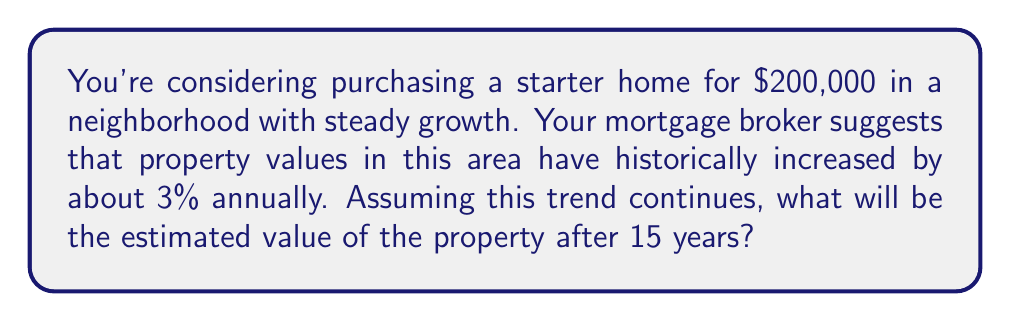Provide a solution to this math problem. To solve this problem, we'll use an exponential growth model. The formula for exponential growth is:

$$A = P(1 + r)^t$$

Where:
$A$ = Final amount
$P$ = Initial principal balance
$r$ = Annual growth rate (as a decimal)
$t$ = Time in years

Given:
$P = $200,000 (initial property value)
$r = 0.03$ (3% annual growth rate)
$t = 15$ years

Let's plug these values into our formula:

$$A = 200,000(1 + 0.03)^{15}$$

Now, let's calculate step by step:

1. Calculate $(1 + 0.03)^{15}$:
   $$(1.03)^{15} \approx 1.5580$$

2. Multiply the result by the initial value:
   $$200,000 \times 1.5580 = 311,600$$

Therefore, after 15 years, the estimated value of the property will be approximately $311,600.
Answer: $311,600 